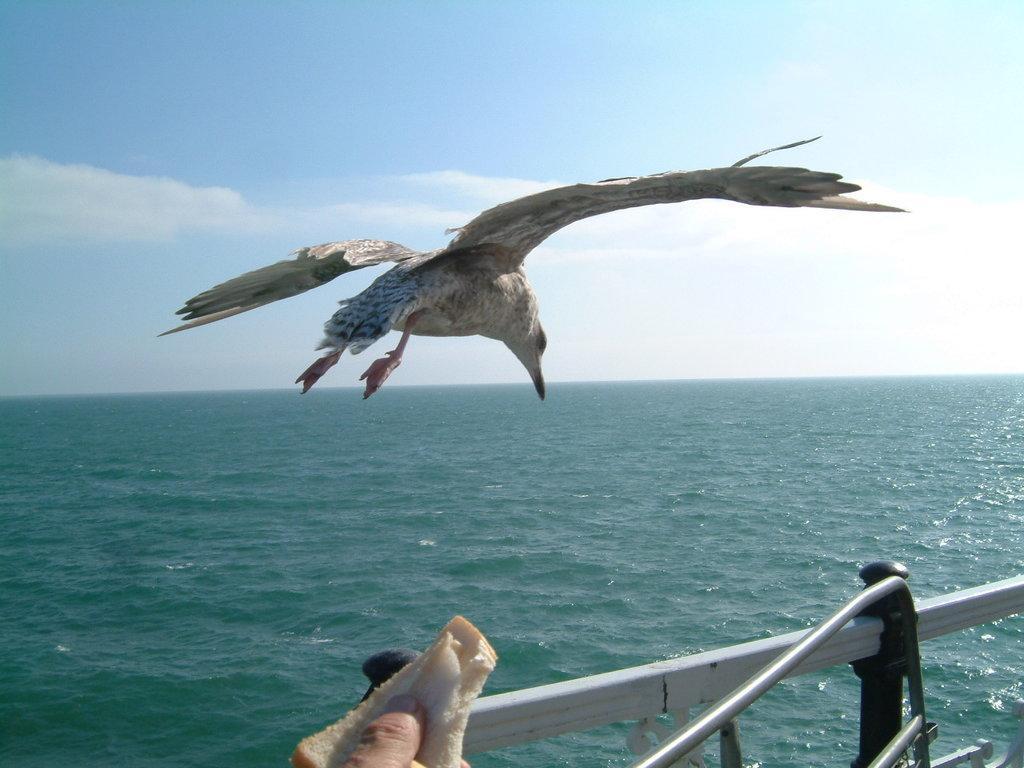Could you give a brief overview of what you see in this image? In the middle of this image, there is a bird flying in the air. At the bottom of this image, there is a hand of a person holding bread and there is a fence. In the background, there is water and there are clouds in the sky. 